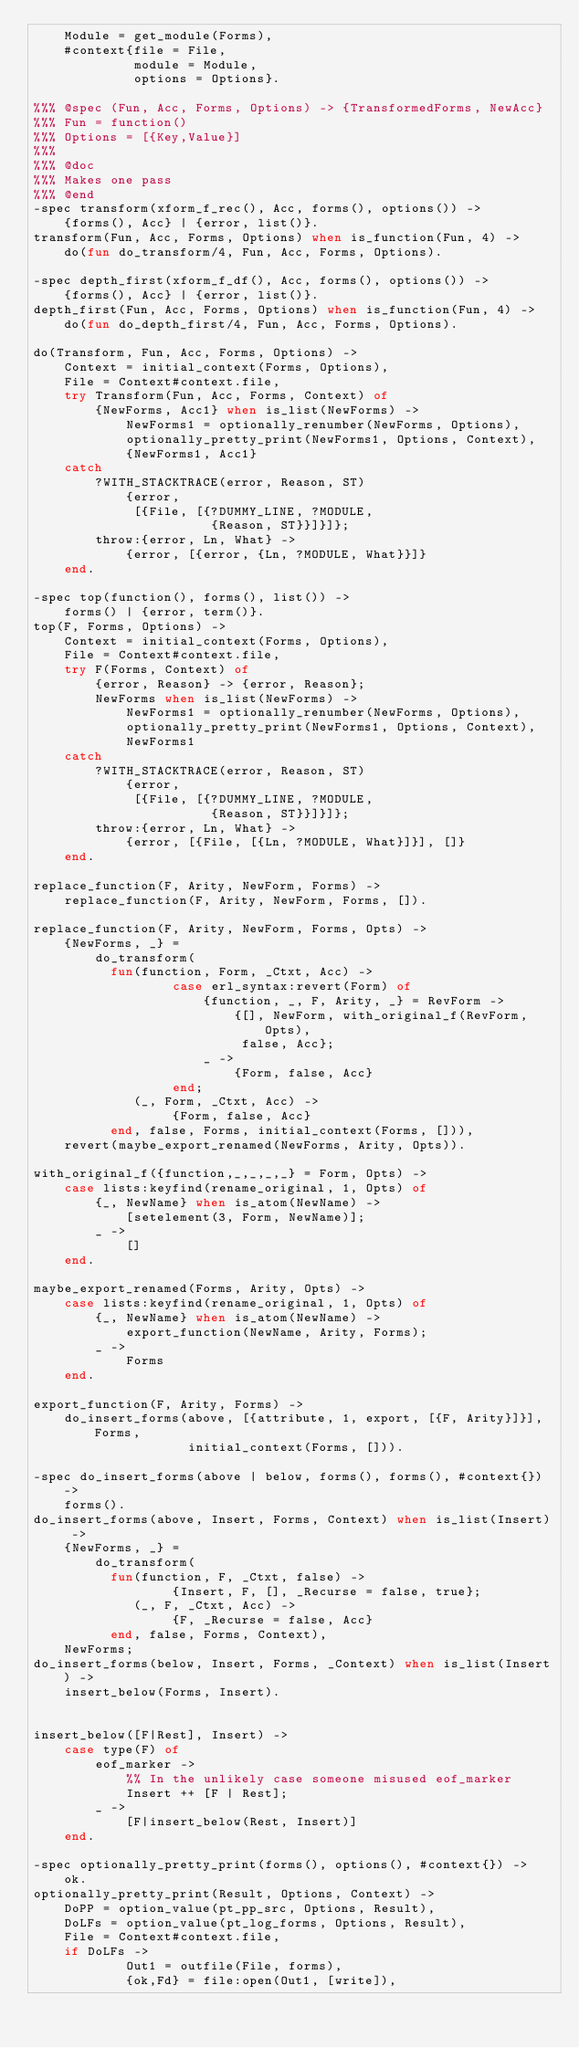<code> <loc_0><loc_0><loc_500><loc_500><_Erlang_>    Module = get_module(Forms),
    #context{file = File,
             module = Module,
             options = Options}.

%%% @spec (Fun, Acc, Forms, Options) -> {TransformedForms, NewAcc}
%%% Fun = function()
%%% Options = [{Key,Value}]
%%%
%%% @doc
%%% Makes one pass
%%% @end
-spec transform(xform_f_rec(), Acc, forms(), options()) ->
    {forms(), Acc} | {error, list()}.
transform(Fun, Acc, Forms, Options) when is_function(Fun, 4) ->
    do(fun do_transform/4, Fun, Acc, Forms, Options).

-spec depth_first(xform_f_df(), Acc, forms(), options()) ->
    {forms(), Acc} | {error, list()}.
depth_first(Fun, Acc, Forms, Options) when is_function(Fun, 4) ->
    do(fun do_depth_first/4, Fun, Acc, Forms, Options).

do(Transform, Fun, Acc, Forms, Options) ->
    Context = initial_context(Forms, Options),
    File = Context#context.file,
    try Transform(Fun, Acc, Forms, Context) of
        {NewForms, Acc1} when is_list(NewForms) ->
            NewForms1 = optionally_renumber(NewForms, Options),
            optionally_pretty_print(NewForms1, Options, Context),
            {NewForms1, Acc1}
    catch
        ?WITH_STACKTRACE(error, Reason, ST)
            {error,
             [{File, [{?DUMMY_LINE, ?MODULE,
                       {Reason, ST}}]}]};
        throw:{error, Ln, What} ->
            {error, [{error, {Ln, ?MODULE, What}}]}
    end.

-spec top(function(), forms(), list()) ->
    forms() | {error, term()}.
top(F, Forms, Options) ->
    Context = initial_context(Forms, Options),
    File = Context#context.file,
    try F(Forms, Context) of
        {error, Reason} -> {error, Reason};
        NewForms when is_list(NewForms) ->
            NewForms1 = optionally_renumber(NewForms, Options),
            optionally_pretty_print(NewForms1, Options, Context),
            NewForms1
    catch
        ?WITH_STACKTRACE(error, Reason, ST)
            {error,
             [{File, [{?DUMMY_LINE, ?MODULE,
                       {Reason, ST}}]}]};
        throw:{error, Ln, What} ->
            {error, [{File, [{Ln, ?MODULE, What}]}], []}
    end.

replace_function(F, Arity, NewForm, Forms) ->
    replace_function(F, Arity, NewForm, Forms, []).

replace_function(F, Arity, NewForm, Forms, Opts) ->
    {NewForms, _} =
        do_transform(
          fun(function, Form, _Ctxt, Acc) ->
                  case erl_syntax:revert(Form) of
                      {function, _, F, Arity, _} = RevForm ->
                          {[], NewForm, with_original_f(RevForm, Opts),
                           false, Acc};
                      _ ->
                          {Form, false, Acc}
                  end;
             (_, Form, _Ctxt, Acc) ->
                  {Form, false, Acc}
          end, false, Forms, initial_context(Forms, [])),
    revert(maybe_export_renamed(NewForms, Arity, Opts)).

with_original_f({function,_,_,_,_} = Form, Opts) ->
    case lists:keyfind(rename_original, 1, Opts) of
        {_, NewName} when is_atom(NewName) ->
            [setelement(3, Form, NewName)];
        _ ->
            []
    end.

maybe_export_renamed(Forms, Arity, Opts) ->
    case lists:keyfind(rename_original, 1, Opts) of
        {_, NewName} when is_atom(NewName) ->
            export_function(NewName, Arity, Forms);
        _ ->
            Forms
    end.

export_function(F, Arity, Forms) ->
    do_insert_forms(above, [{attribute, 1, export, [{F, Arity}]}], Forms,
                    initial_context(Forms, [])).

-spec do_insert_forms(above | below, forms(), forms(), #context{}) ->
    forms().
do_insert_forms(above, Insert, Forms, Context) when is_list(Insert) ->
    {NewForms, _} =
        do_transform(
          fun(function, F, _Ctxt, false) ->
                  {Insert, F, [], _Recurse = false, true};
             (_, F, _Ctxt, Acc) ->
                  {F, _Recurse = false, Acc}
          end, false, Forms, Context),
    NewForms;
do_insert_forms(below, Insert, Forms, _Context) when is_list(Insert) ->
    insert_below(Forms, Insert).


insert_below([F|Rest], Insert) ->
    case type(F) of
        eof_marker ->
            %% In the unlikely case someone misused eof_marker
            Insert ++ [F | Rest];
        _ ->
            [F|insert_below(Rest, Insert)]
    end.

-spec optionally_pretty_print(forms(), options(), #context{}) ->
    ok.
optionally_pretty_print(Result, Options, Context) ->
    DoPP = option_value(pt_pp_src, Options, Result),
    DoLFs = option_value(pt_log_forms, Options, Result),
    File = Context#context.file,
    if DoLFs ->
            Out1 = outfile(File, forms),
            {ok,Fd} = file:open(Out1, [write]),</code> 